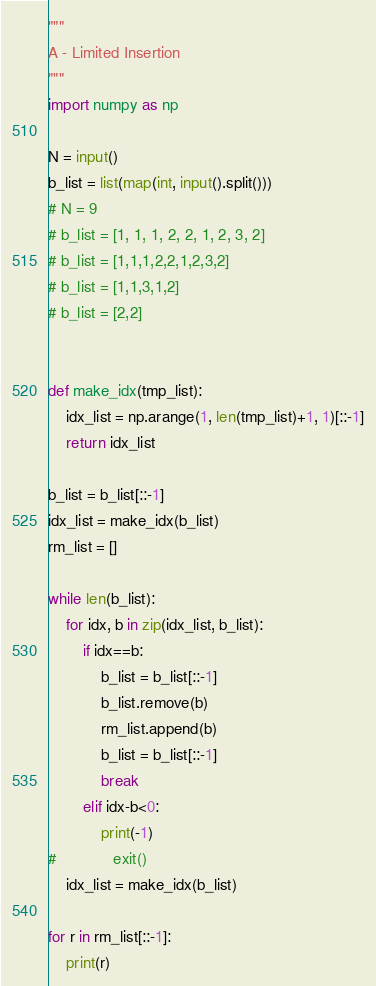<code> <loc_0><loc_0><loc_500><loc_500><_Python_>"""
A - Limited Insertion
"""
import numpy as np

N = input()
b_list = list(map(int, input().split()))
# N = 9
# b_list = [1, 1, 1, 2, 2, 1, 2, 3, 2]
# b_list = [1,1,1,2,2,1,2,3,2]
# b_list = [1,1,3,1,2]
# b_list = [2,2]


def make_idx(tmp_list):
    idx_list = np.arange(1, len(tmp_list)+1, 1)[::-1]
    return idx_list

b_list = b_list[::-1]
idx_list = make_idx(b_list)
rm_list = []

while len(b_list):
    for idx, b in zip(idx_list, b_list):
        if idx==b:
            b_list = b_list[::-1]
            b_list.remove(b)
            rm_list.append(b)
            b_list = b_list[::-1]
            break
        elif idx-b<0:
            print(-1)
#             exit()
    idx_list = make_idx(b_list)
    
for r in rm_list[::-1]:
    print(r)</code> 